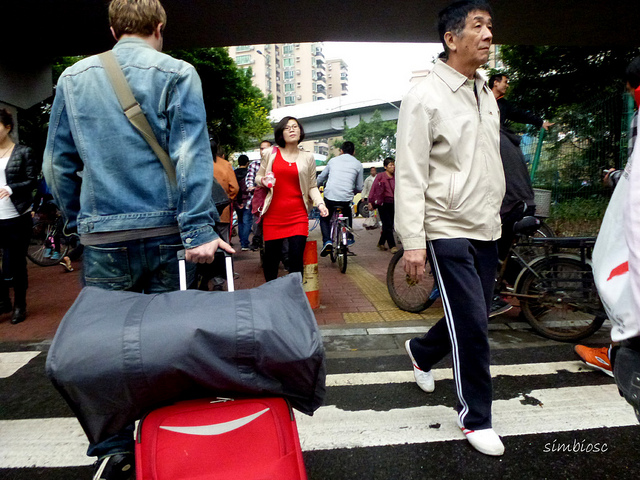Identify the text displayed in this image. s&#237;mb&#237;ose 